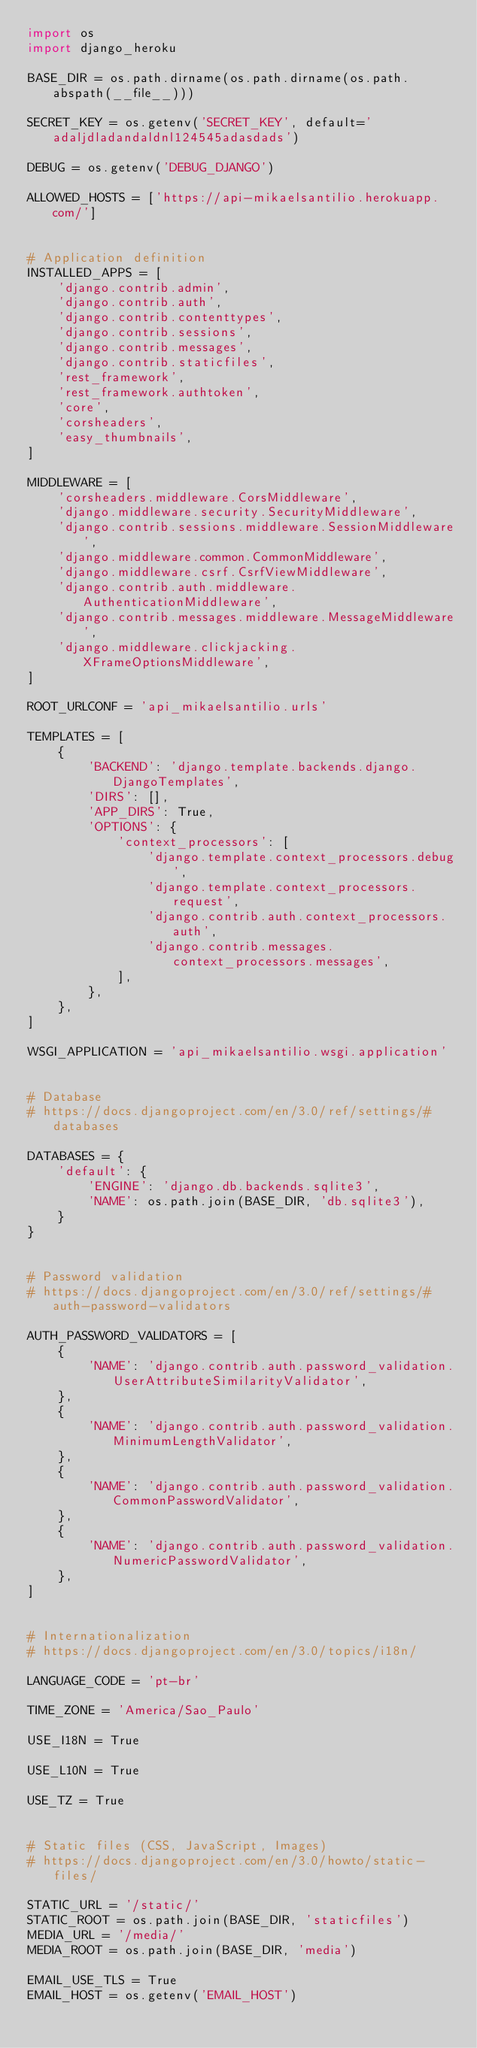<code> <loc_0><loc_0><loc_500><loc_500><_Python_>import os
import django_heroku

BASE_DIR = os.path.dirname(os.path.dirname(os.path.abspath(__file__)))

SECRET_KEY = os.getenv('SECRET_KEY', default='adaljdladandaldnl124545adasdads')

DEBUG = os.getenv('DEBUG_DJANGO')

ALLOWED_HOSTS = ['https://api-mikaelsantilio.herokuapp.com/']


# Application definition
INSTALLED_APPS = [
    'django.contrib.admin',
    'django.contrib.auth',
    'django.contrib.contenttypes',
    'django.contrib.sessions',
    'django.contrib.messages',
    'django.contrib.staticfiles',
    'rest_framework',
    'rest_framework.authtoken',
    'core',
    'corsheaders',
    'easy_thumbnails',
]

MIDDLEWARE = [
    'corsheaders.middleware.CorsMiddleware',
    'django.middleware.security.SecurityMiddleware',
    'django.contrib.sessions.middleware.SessionMiddleware',
    'django.middleware.common.CommonMiddleware',
    'django.middleware.csrf.CsrfViewMiddleware',
    'django.contrib.auth.middleware.AuthenticationMiddleware',
    'django.contrib.messages.middleware.MessageMiddleware',
    'django.middleware.clickjacking.XFrameOptionsMiddleware',
]

ROOT_URLCONF = 'api_mikaelsantilio.urls'

TEMPLATES = [
    {
        'BACKEND': 'django.template.backends.django.DjangoTemplates',
        'DIRS': [],
        'APP_DIRS': True,
        'OPTIONS': {
            'context_processors': [
                'django.template.context_processors.debug',
                'django.template.context_processors.request',
                'django.contrib.auth.context_processors.auth',
                'django.contrib.messages.context_processors.messages',
            ],
        },
    },
]

WSGI_APPLICATION = 'api_mikaelsantilio.wsgi.application'


# Database
# https://docs.djangoproject.com/en/3.0/ref/settings/#databases

DATABASES = {
    'default': {
        'ENGINE': 'django.db.backends.sqlite3',
        'NAME': os.path.join(BASE_DIR, 'db.sqlite3'),
    }
}


# Password validation
# https://docs.djangoproject.com/en/3.0/ref/settings/#auth-password-validators

AUTH_PASSWORD_VALIDATORS = [
    {
        'NAME': 'django.contrib.auth.password_validation.UserAttributeSimilarityValidator',
    },
    {
        'NAME': 'django.contrib.auth.password_validation.MinimumLengthValidator',
    },
    {
        'NAME': 'django.contrib.auth.password_validation.CommonPasswordValidator',
    },
    {
        'NAME': 'django.contrib.auth.password_validation.NumericPasswordValidator',
    },
]


# Internationalization
# https://docs.djangoproject.com/en/3.0/topics/i18n/

LANGUAGE_CODE = 'pt-br'

TIME_ZONE = 'America/Sao_Paulo'

USE_I18N = True

USE_L10N = True

USE_TZ = True


# Static files (CSS, JavaScript, Images)
# https://docs.djangoproject.com/en/3.0/howto/static-files/

STATIC_URL = '/static/'
STATIC_ROOT = os.path.join(BASE_DIR, 'staticfiles')
MEDIA_URL = '/media/'
MEDIA_ROOT = os.path.join(BASE_DIR, 'media')

EMAIL_USE_TLS = True
EMAIL_HOST = os.getenv('EMAIL_HOST')</code> 